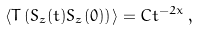<formula> <loc_0><loc_0><loc_500><loc_500>\langle T \left ( S _ { z } ( t ) S _ { z } ( 0 ) \right ) \rangle = C t ^ { - 2 x } \, ,</formula> 